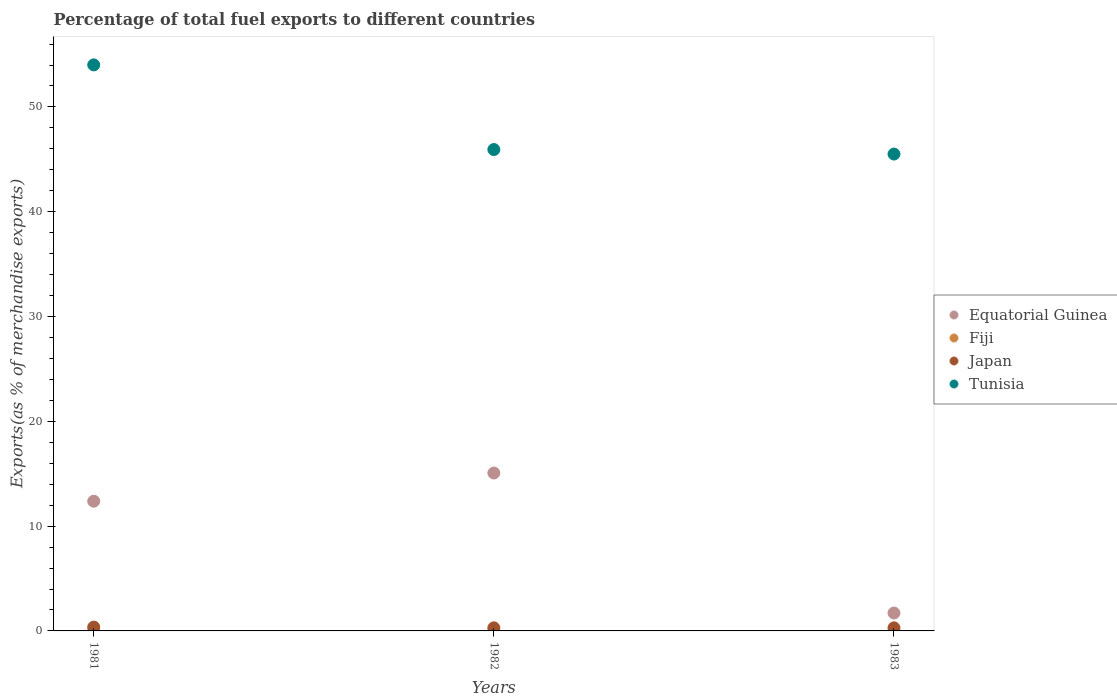How many different coloured dotlines are there?
Ensure brevity in your answer.  4. Is the number of dotlines equal to the number of legend labels?
Your answer should be compact. Yes. What is the percentage of exports to different countries in Japan in 1983?
Make the answer very short. 0.29. Across all years, what is the maximum percentage of exports to different countries in Equatorial Guinea?
Your answer should be very brief. 15.07. Across all years, what is the minimum percentage of exports to different countries in Japan?
Give a very brief answer. 0.29. In which year was the percentage of exports to different countries in Tunisia maximum?
Ensure brevity in your answer.  1981. What is the total percentage of exports to different countries in Tunisia in the graph?
Offer a very short reply. 145.46. What is the difference between the percentage of exports to different countries in Tunisia in 1981 and that in 1983?
Provide a short and direct response. 8.51. What is the difference between the percentage of exports to different countries in Equatorial Guinea in 1981 and the percentage of exports to different countries in Tunisia in 1982?
Make the answer very short. -33.56. What is the average percentage of exports to different countries in Fiji per year?
Make the answer very short. 0. In the year 1983, what is the difference between the percentage of exports to different countries in Japan and percentage of exports to different countries in Fiji?
Offer a terse response. 0.29. In how many years, is the percentage of exports to different countries in Fiji greater than 14 %?
Your response must be concise. 0. What is the ratio of the percentage of exports to different countries in Tunisia in 1981 to that in 1983?
Your answer should be compact. 1.19. Is the difference between the percentage of exports to different countries in Japan in 1981 and 1983 greater than the difference between the percentage of exports to different countries in Fiji in 1981 and 1983?
Ensure brevity in your answer.  Yes. What is the difference between the highest and the second highest percentage of exports to different countries in Fiji?
Your response must be concise. 0. What is the difference between the highest and the lowest percentage of exports to different countries in Tunisia?
Provide a succinct answer. 8.51. In how many years, is the percentage of exports to different countries in Equatorial Guinea greater than the average percentage of exports to different countries in Equatorial Guinea taken over all years?
Offer a very short reply. 2. Is the percentage of exports to different countries in Japan strictly greater than the percentage of exports to different countries in Tunisia over the years?
Offer a terse response. No. How many dotlines are there?
Your answer should be compact. 4. How many years are there in the graph?
Your answer should be compact. 3. What is the difference between two consecutive major ticks on the Y-axis?
Keep it short and to the point. 10. Does the graph contain any zero values?
Provide a succinct answer. No. How many legend labels are there?
Your answer should be compact. 4. What is the title of the graph?
Give a very brief answer. Percentage of total fuel exports to different countries. Does "Ukraine" appear as one of the legend labels in the graph?
Make the answer very short. No. What is the label or title of the X-axis?
Your answer should be compact. Years. What is the label or title of the Y-axis?
Offer a very short reply. Exports(as % of merchandise exports). What is the Exports(as % of merchandise exports) of Equatorial Guinea in 1981?
Make the answer very short. 12.38. What is the Exports(as % of merchandise exports) of Fiji in 1981?
Your answer should be compact. 0. What is the Exports(as % of merchandise exports) of Japan in 1981?
Give a very brief answer. 0.36. What is the Exports(as % of merchandise exports) of Tunisia in 1981?
Your answer should be very brief. 54.02. What is the Exports(as % of merchandise exports) of Equatorial Guinea in 1982?
Give a very brief answer. 15.07. What is the Exports(as % of merchandise exports) in Fiji in 1982?
Offer a terse response. 4.97172309888766e-5. What is the Exports(as % of merchandise exports) of Japan in 1982?
Keep it short and to the point. 0.3. What is the Exports(as % of merchandise exports) of Tunisia in 1982?
Your answer should be compact. 45.94. What is the Exports(as % of merchandise exports) in Equatorial Guinea in 1983?
Ensure brevity in your answer.  1.71. What is the Exports(as % of merchandise exports) of Fiji in 1983?
Make the answer very short. 0. What is the Exports(as % of merchandise exports) of Japan in 1983?
Make the answer very short. 0.29. What is the Exports(as % of merchandise exports) of Tunisia in 1983?
Keep it short and to the point. 45.5. Across all years, what is the maximum Exports(as % of merchandise exports) of Equatorial Guinea?
Offer a terse response. 15.07. Across all years, what is the maximum Exports(as % of merchandise exports) of Fiji?
Offer a very short reply. 0. Across all years, what is the maximum Exports(as % of merchandise exports) of Japan?
Keep it short and to the point. 0.36. Across all years, what is the maximum Exports(as % of merchandise exports) of Tunisia?
Provide a short and direct response. 54.02. Across all years, what is the minimum Exports(as % of merchandise exports) of Equatorial Guinea?
Give a very brief answer. 1.71. Across all years, what is the minimum Exports(as % of merchandise exports) in Fiji?
Keep it short and to the point. 4.97172309888766e-5. Across all years, what is the minimum Exports(as % of merchandise exports) in Japan?
Your answer should be very brief. 0.29. Across all years, what is the minimum Exports(as % of merchandise exports) of Tunisia?
Offer a very short reply. 45.5. What is the total Exports(as % of merchandise exports) of Equatorial Guinea in the graph?
Make the answer very short. 29.16. What is the total Exports(as % of merchandise exports) of Fiji in the graph?
Your response must be concise. 0. What is the total Exports(as % of merchandise exports) of Japan in the graph?
Offer a terse response. 0.96. What is the total Exports(as % of merchandise exports) in Tunisia in the graph?
Provide a short and direct response. 145.46. What is the difference between the Exports(as % of merchandise exports) in Equatorial Guinea in 1981 and that in 1982?
Give a very brief answer. -2.69. What is the difference between the Exports(as % of merchandise exports) in Japan in 1981 and that in 1982?
Your answer should be compact. 0.07. What is the difference between the Exports(as % of merchandise exports) in Tunisia in 1981 and that in 1982?
Provide a short and direct response. 8.08. What is the difference between the Exports(as % of merchandise exports) in Equatorial Guinea in 1981 and that in 1983?
Your answer should be very brief. 10.67. What is the difference between the Exports(as % of merchandise exports) in Japan in 1981 and that in 1983?
Your answer should be compact. 0.07. What is the difference between the Exports(as % of merchandise exports) of Tunisia in 1981 and that in 1983?
Provide a short and direct response. 8.51. What is the difference between the Exports(as % of merchandise exports) in Equatorial Guinea in 1982 and that in 1983?
Give a very brief answer. 13.36. What is the difference between the Exports(as % of merchandise exports) of Fiji in 1982 and that in 1983?
Your response must be concise. -0. What is the difference between the Exports(as % of merchandise exports) of Japan in 1982 and that in 1983?
Keep it short and to the point. 0. What is the difference between the Exports(as % of merchandise exports) in Tunisia in 1982 and that in 1983?
Offer a terse response. 0.43. What is the difference between the Exports(as % of merchandise exports) of Equatorial Guinea in 1981 and the Exports(as % of merchandise exports) of Fiji in 1982?
Make the answer very short. 12.38. What is the difference between the Exports(as % of merchandise exports) of Equatorial Guinea in 1981 and the Exports(as % of merchandise exports) of Japan in 1982?
Your answer should be compact. 12.08. What is the difference between the Exports(as % of merchandise exports) in Equatorial Guinea in 1981 and the Exports(as % of merchandise exports) in Tunisia in 1982?
Your response must be concise. -33.56. What is the difference between the Exports(as % of merchandise exports) in Fiji in 1981 and the Exports(as % of merchandise exports) in Japan in 1982?
Ensure brevity in your answer.  -0.3. What is the difference between the Exports(as % of merchandise exports) in Fiji in 1981 and the Exports(as % of merchandise exports) in Tunisia in 1982?
Provide a succinct answer. -45.94. What is the difference between the Exports(as % of merchandise exports) of Japan in 1981 and the Exports(as % of merchandise exports) of Tunisia in 1982?
Your answer should be very brief. -45.57. What is the difference between the Exports(as % of merchandise exports) in Equatorial Guinea in 1981 and the Exports(as % of merchandise exports) in Fiji in 1983?
Offer a very short reply. 12.38. What is the difference between the Exports(as % of merchandise exports) in Equatorial Guinea in 1981 and the Exports(as % of merchandise exports) in Japan in 1983?
Your response must be concise. 12.08. What is the difference between the Exports(as % of merchandise exports) of Equatorial Guinea in 1981 and the Exports(as % of merchandise exports) of Tunisia in 1983?
Give a very brief answer. -33.13. What is the difference between the Exports(as % of merchandise exports) in Fiji in 1981 and the Exports(as % of merchandise exports) in Japan in 1983?
Keep it short and to the point. -0.29. What is the difference between the Exports(as % of merchandise exports) of Fiji in 1981 and the Exports(as % of merchandise exports) of Tunisia in 1983?
Your response must be concise. -45.5. What is the difference between the Exports(as % of merchandise exports) in Japan in 1981 and the Exports(as % of merchandise exports) in Tunisia in 1983?
Offer a very short reply. -45.14. What is the difference between the Exports(as % of merchandise exports) of Equatorial Guinea in 1982 and the Exports(as % of merchandise exports) of Fiji in 1983?
Your answer should be very brief. 15.07. What is the difference between the Exports(as % of merchandise exports) of Equatorial Guinea in 1982 and the Exports(as % of merchandise exports) of Japan in 1983?
Provide a short and direct response. 14.78. What is the difference between the Exports(as % of merchandise exports) in Equatorial Guinea in 1982 and the Exports(as % of merchandise exports) in Tunisia in 1983?
Provide a succinct answer. -30.43. What is the difference between the Exports(as % of merchandise exports) in Fiji in 1982 and the Exports(as % of merchandise exports) in Japan in 1983?
Your answer should be compact. -0.29. What is the difference between the Exports(as % of merchandise exports) in Fiji in 1982 and the Exports(as % of merchandise exports) in Tunisia in 1983?
Offer a very short reply. -45.5. What is the difference between the Exports(as % of merchandise exports) in Japan in 1982 and the Exports(as % of merchandise exports) in Tunisia in 1983?
Your answer should be compact. -45.21. What is the average Exports(as % of merchandise exports) of Equatorial Guinea per year?
Give a very brief answer. 9.72. What is the average Exports(as % of merchandise exports) of Fiji per year?
Provide a succinct answer. 0. What is the average Exports(as % of merchandise exports) of Japan per year?
Your answer should be very brief. 0.32. What is the average Exports(as % of merchandise exports) in Tunisia per year?
Ensure brevity in your answer.  48.49. In the year 1981, what is the difference between the Exports(as % of merchandise exports) of Equatorial Guinea and Exports(as % of merchandise exports) of Fiji?
Your answer should be very brief. 12.38. In the year 1981, what is the difference between the Exports(as % of merchandise exports) in Equatorial Guinea and Exports(as % of merchandise exports) in Japan?
Ensure brevity in your answer.  12.01. In the year 1981, what is the difference between the Exports(as % of merchandise exports) in Equatorial Guinea and Exports(as % of merchandise exports) in Tunisia?
Your answer should be compact. -41.64. In the year 1981, what is the difference between the Exports(as % of merchandise exports) in Fiji and Exports(as % of merchandise exports) in Japan?
Offer a terse response. -0.36. In the year 1981, what is the difference between the Exports(as % of merchandise exports) in Fiji and Exports(as % of merchandise exports) in Tunisia?
Your response must be concise. -54.01. In the year 1981, what is the difference between the Exports(as % of merchandise exports) in Japan and Exports(as % of merchandise exports) in Tunisia?
Make the answer very short. -53.65. In the year 1982, what is the difference between the Exports(as % of merchandise exports) in Equatorial Guinea and Exports(as % of merchandise exports) in Fiji?
Provide a short and direct response. 15.07. In the year 1982, what is the difference between the Exports(as % of merchandise exports) of Equatorial Guinea and Exports(as % of merchandise exports) of Japan?
Your response must be concise. 14.77. In the year 1982, what is the difference between the Exports(as % of merchandise exports) in Equatorial Guinea and Exports(as % of merchandise exports) in Tunisia?
Your answer should be very brief. -30.87. In the year 1982, what is the difference between the Exports(as % of merchandise exports) in Fiji and Exports(as % of merchandise exports) in Japan?
Keep it short and to the point. -0.3. In the year 1982, what is the difference between the Exports(as % of merchandise exports) of Fiji and Exports(as % of merchandise exports) of Tunisia?
Ensure brevity in your answer.  -45.94. In the year 1982, what is the difference between the Exports(as % of merchandise exports) of Japan and Exports(as % of merchandise exports) of Tunisia?
Give a very brief answer. -45.64. In the year 1983, what is the difference between the Exports(as % of merchandise exports) in Equatorial Guinea and Exports(as % of merchandise exports) in Fiji?
Make the answer very short. 1.71. In the year 1983, what is the difference between the Exports(as % of merchandise exports) of Equatorial Guinea and Exports(as % of merchandise exports) of Japan?
Offer a terse response. 1.41. In the year 1983, what is the difference between the Exports(as % of merchandise exports) of Equatorial Guinea and Exports(as % of merchandise exports) of Tunisia?
Offer a very short reply. -43.8. In the year 1983, what is the difference between the Exports(as % of merchandise exports) in Fiji and Exports(as % of merchandise exports) in Japan?
Your answer should be very brief. -0.29. In the year 1983, what is the difference between the Exports(as % of merchandise exports) in Fiji and Exports(as % of merchandise exports) in Tunisia?
Offer a very short reply. -45.5. In the year 1983, what is the difference between the Exports(as % of merchandise exports) of Japan and Exports(as % of merchandise exports) of Tunisia?
Give a very brief answer. -45.21. What is the ratio of the Exports(as % of merchandise exports) of Equatorial Guinea in 1981 to that in 1982?
Your answer should be compact. 0.82. What is the ratio of the Exports(as % of merchandise exports) in Fiji in 1981 to that in 1982?
Offer a very short reply. 11.81. What is the ratio of the Exports(as % of merchandise exports) of Japan in 1981 to that in 1982?
Offer a very short reply. 1.23. What is the ratio of the Exports(as % of merchandise exports) of Tunisia in 1981 to that in 1982?
Offer a very short reply. 1.18. What is the ratio of the Exports(as % of merchandise exports) in Equatorial Guinea in 1981 to that in 1983?
Offer a terse response. 7.24. What is the ratio of the Exports(as % of merchandise exports) in Fiji in 1981 to that in 1983?
Ensure brevity in your answer.  1.62. What is the ratio of the Exports(as % of merchandise exports) in Japan in 1981 to that in 1983?
Ensure brevity in your answer.  1.24. What is the ratio of the Exports(as % of merchandise exports) in Tunisia in 1981 to that in 1983?
Your response must be concise. 1.19. What is the ratio of the Exports(as % of merchandise exports) in Equatorial Guinea in 1982 to that in 1983?
Provide a short and direct response. 8.82. What is the ratio of the Exports(as % of merchandise exports) of Fiji in 1982 to that in 1983?
Make the answer very short. 0.14. What is the ratio of the Exports(as % of merchandise exports) in Tunisia in 1982 to that in 1983?
Offer a very short reply. 1.01. What is the difference between the highest and the second highest Exports(as % of merchandise exports) of Equatorial Guinea?
Keep it short and to the point. 2.69. What is the difference between the highest and the second highest Exports(as % of merchandise exports) in Japan?
Provide a short and direct response. 0.07. What is the difference between the highest and the second highest Exports(as % of merchandise exports) of Tunisia?
Make the answer very short. 8.08. What is the difference between the highest and the lowest Exports(as % of merchandise exports) in Equatorial Guinea?
Ensure brevity in your answer.  13.36. What is the difference between the highest and the lowest Exports(as % of merchandise exports) of Japan?
Provide a short and direct response. 0.07. What is the difference between the highest and the lowest Exports(as % of merchandise exports) of Tunisia?
Your answer should be very brief. 8.51. 